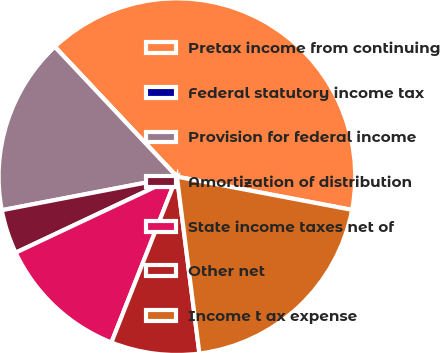Convert chart to OTSL. <chart><loc_0><loc_0><loc_500><loc_500><pie_chart><fcel>Pretax income from continuing<fcel>Federal statutory income tax<fcel>Provision for federal income<fcel>Amortization of distribution<fcel>State income taxes net of<fcel>Other net<fcel>Income t ax expense<nl><fcel>39.99%<fcel>0.0%<fcel>16.0%<fcel>4.0%<fcel>12.0%<fcel>8.0%<fcel>20.0%<nl></chart> 